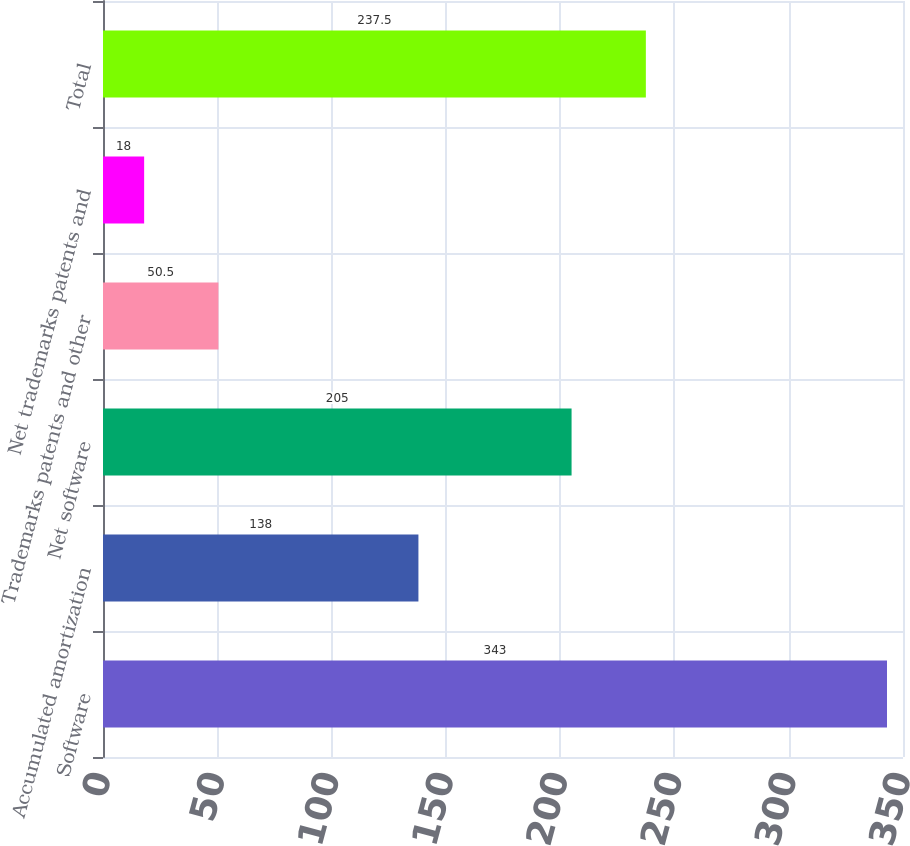<chart> <loc_0><loc_0><loc_500><loc_500><bar_chart><fcel>Software<fcel>Accumulated amortization<fcel>Net software<fcel>Trademarks patents and other<fcel>Net trademarks patents and<fcel>Total<nl><fcel>343<fcel>138<fcel>205<fcel>50.5<fcel>18<fcel>237.5<nl></chart> 